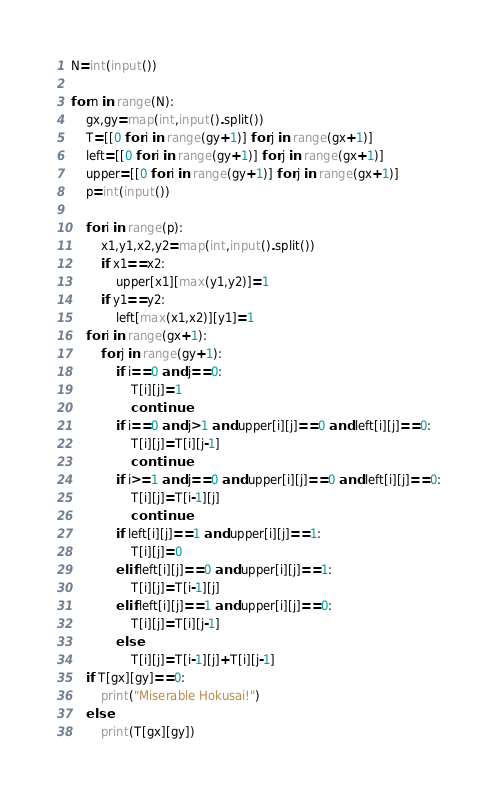Convert code to text. <code><loc_0><loc_0><loc_500><loc_500><_Python_>N=int(input())

for n in range(N):
    gx,gy=map(int,input().split())
    T=[[0 for i in range(gy+1)] for j in range(gx+1)]
    left=[[0 for i in range(gy+1)] for j in range(gx+1)] 
    upper=[[0 for i in range(gy+1)] for j in range(gx+1)]
    p=int(input())
    
    for i in range(p):
        x1,y1,x2,y2=map(int,input().split())
        if x1==x2:
            upper[x1][max(y1,y2)]=1
        if y1==y2:
            left[max(x1,x2)][y1]=1
    for i in range(gx+1):
        for j in range(gy+1):
            if i==0 and j==0:
                T[i][j]=1
                continue
            if i==0 and j>1 and upper[i][j]==0 and left[i][j]==0:
                T[i][j]=T[i][j-1]
                continue
            if i>=1 and j==0 and upper[i][j]==0 and left[i][j]==0:
                T[i][j]=T[i-1][j]
                continue
            if left[i][j]==1 and upper[i][j]==1:
                T[i][j]=0
            elif left[i][j]==0 and upper[i][j]==1:
                T[i][j]=T[i-1][j]
            elif left[i][j]==1 and upper[i][j]==0:
                T[i][j]=T[i][j-1]
            else:
                T[i][j]=T[i-1][j]+T[i][j-1]
    if T[gx][gy]==0:
        print("Miserable Hokusai!")
    else:
        print(T[gx][gy])
</code> 